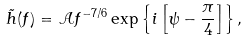<formula> <loc_0><loc_0><loc_500><loc_500>\tilde { h } ( f ) = { \mathcal { A } } f ^ { - 7 / 6 } \exp \left \{ i \left [ \psi - \frac { \pi } { 4 } \right ] \right \} ,</formula> 